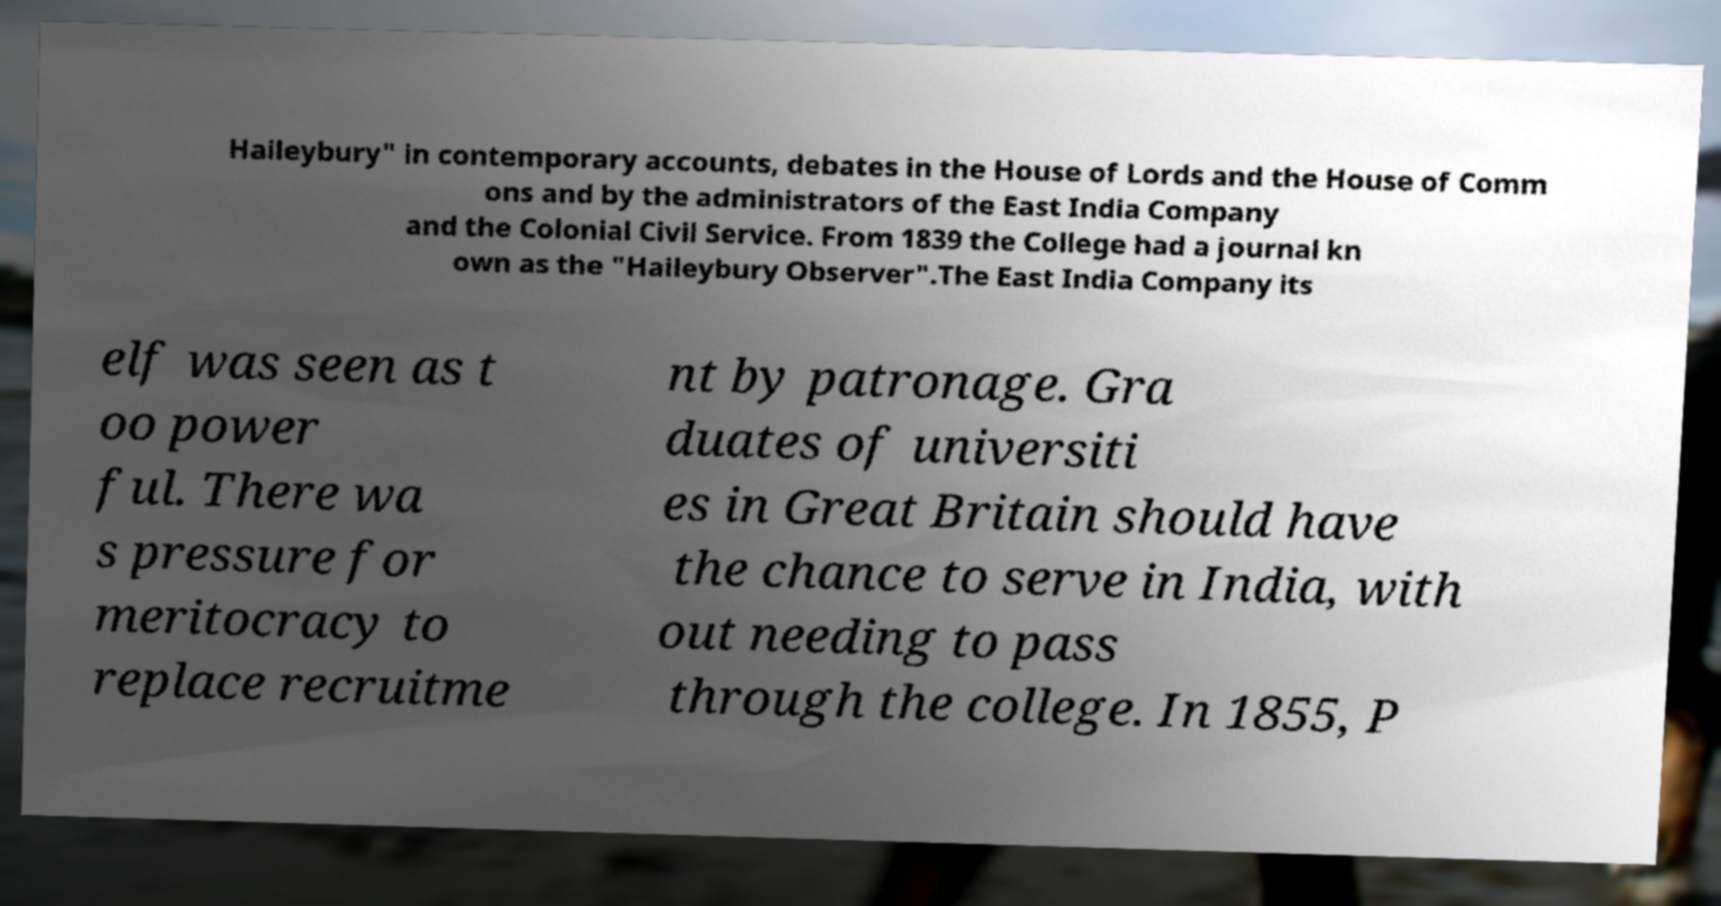Can you read and provide the text displayed in the image?This photo seems to have some interesting text. Can you extract and type it out for me? Haileybury" in contemporary accounts, debates in the House of Lords and the House of Comm ons and by the administrators of the East India Company and the Colonial Civil Service. From 1839 the College had a journal kn own as the "Haileybury Observer".The East India Company its elf was seen as t oo power ful. There wa s pressure for meritocracy to replace recruitme nt by patronage. Gra duates of universiti es in Great Britain should have the chance to serve in India, with out needing to pass through the college. In 1855, P 